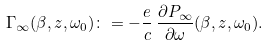<formula> <loc_0><loc_0><loc_500><loc_500>\Gamma _ { \infty } ( \beta , z , \omega _ { 0 } ) \colon = - \frac { e } { c } \, \frac { \partial P _ { \infty } } { \partial \omega } ( \beta , z , \omega _ { 0 } ) .</formula> 